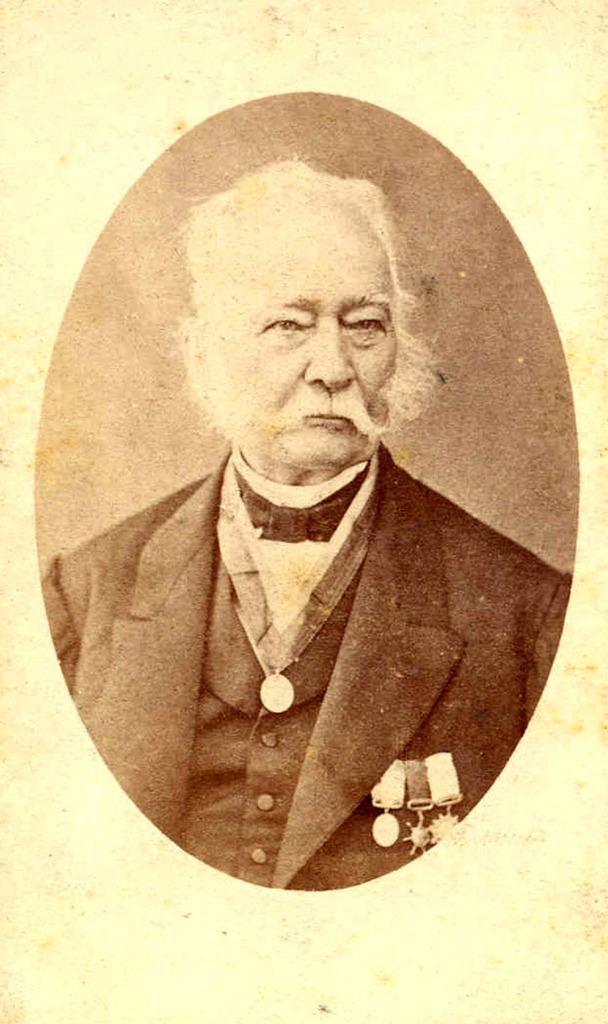What is the main subject of the image? The main subject of the image is a photo of an old man. What is the old man wearing in the image? The old man is wearing a blazer in the image. Are there any accessories visible on the old man? Yes, the old man is wearing badges in the image. What type of glove is the old man wearing in the image? There is no glove visible on the old man in the image. Can you describe the nose of the old man in the image? The image is a photo, and it does not provide a detailed view of the old man's nose. 